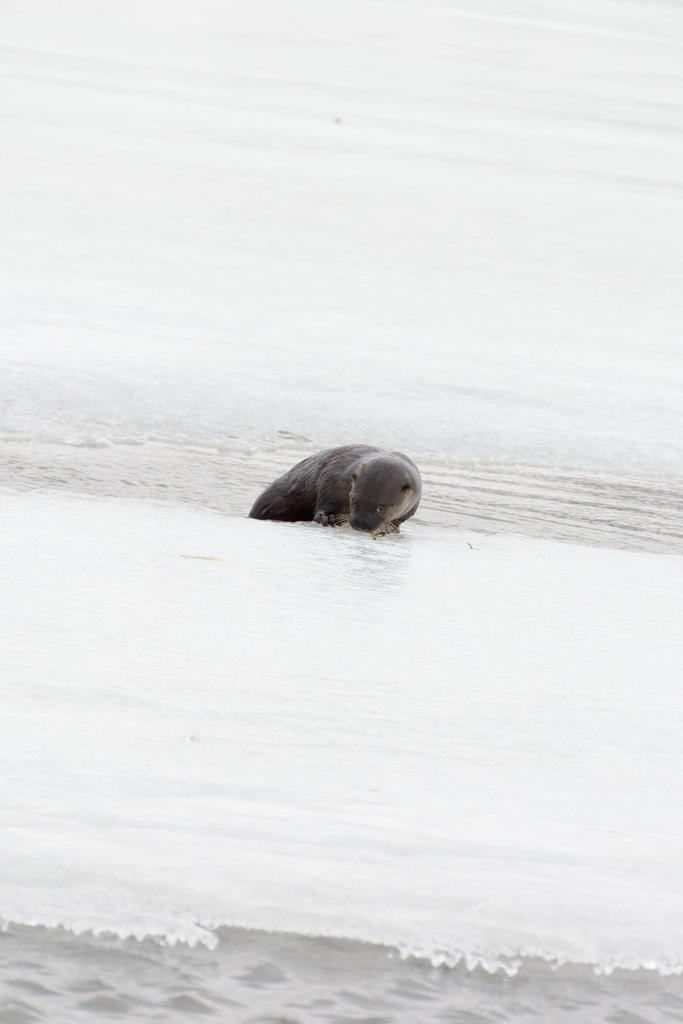What is located in the foreground of the picture? There is ice in the foreground of the picture. What animal can be seen in the center of the picture? There is a seal in the center of the picture. What is present at the top of the picture? There is water and ice at the top of the picture. How many slaves are visible in the picture? There are no slaves present in the picture; it features ice, water, and a seal. Can you tell me how many snakes are slithering in the ice? There are no snakes present in the picture; it features ice, water, and a seal. 